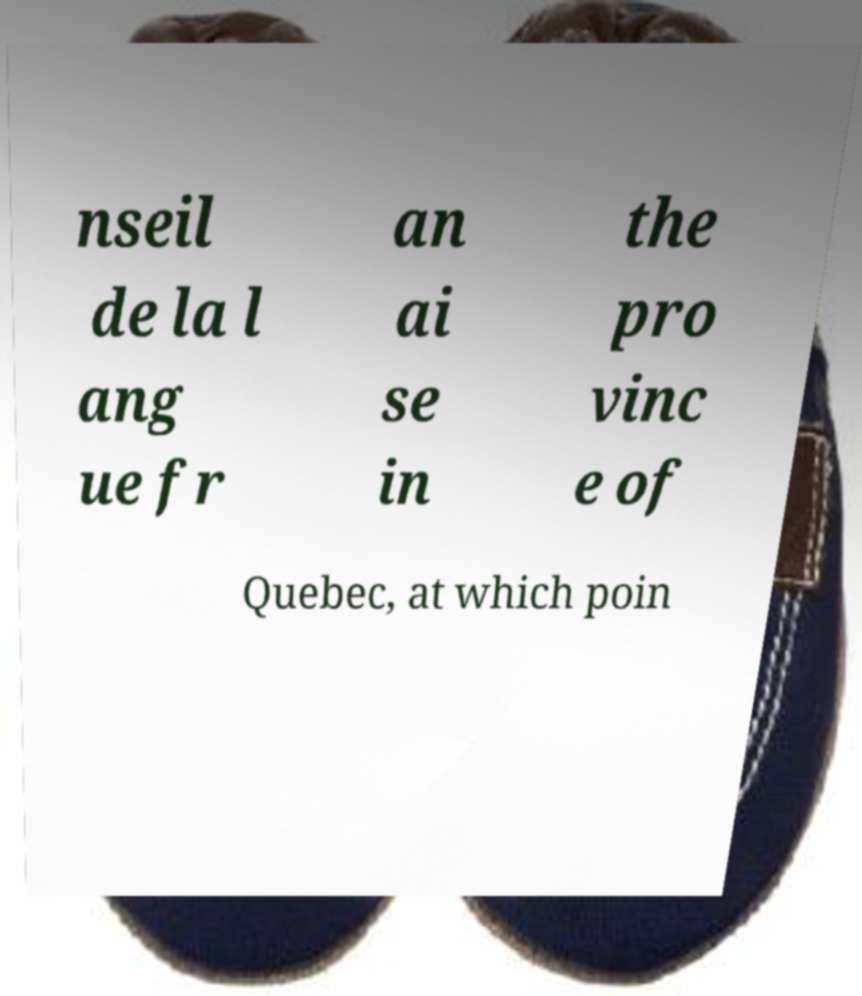For documentation purposes, I need the text within this image transcribed. Could you provide that? nseil de la l ang ue fr an ai se in the pro vinc e of Quebec, at which poin 